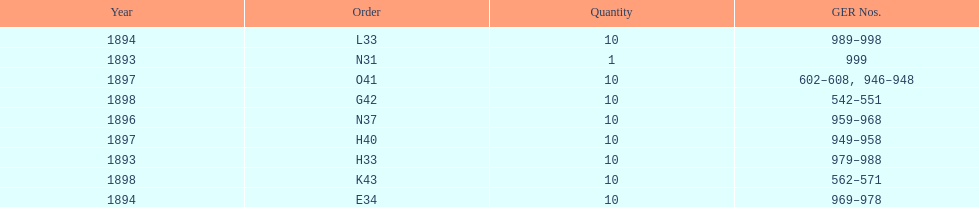How mans years have ger nos below 900? 2. 